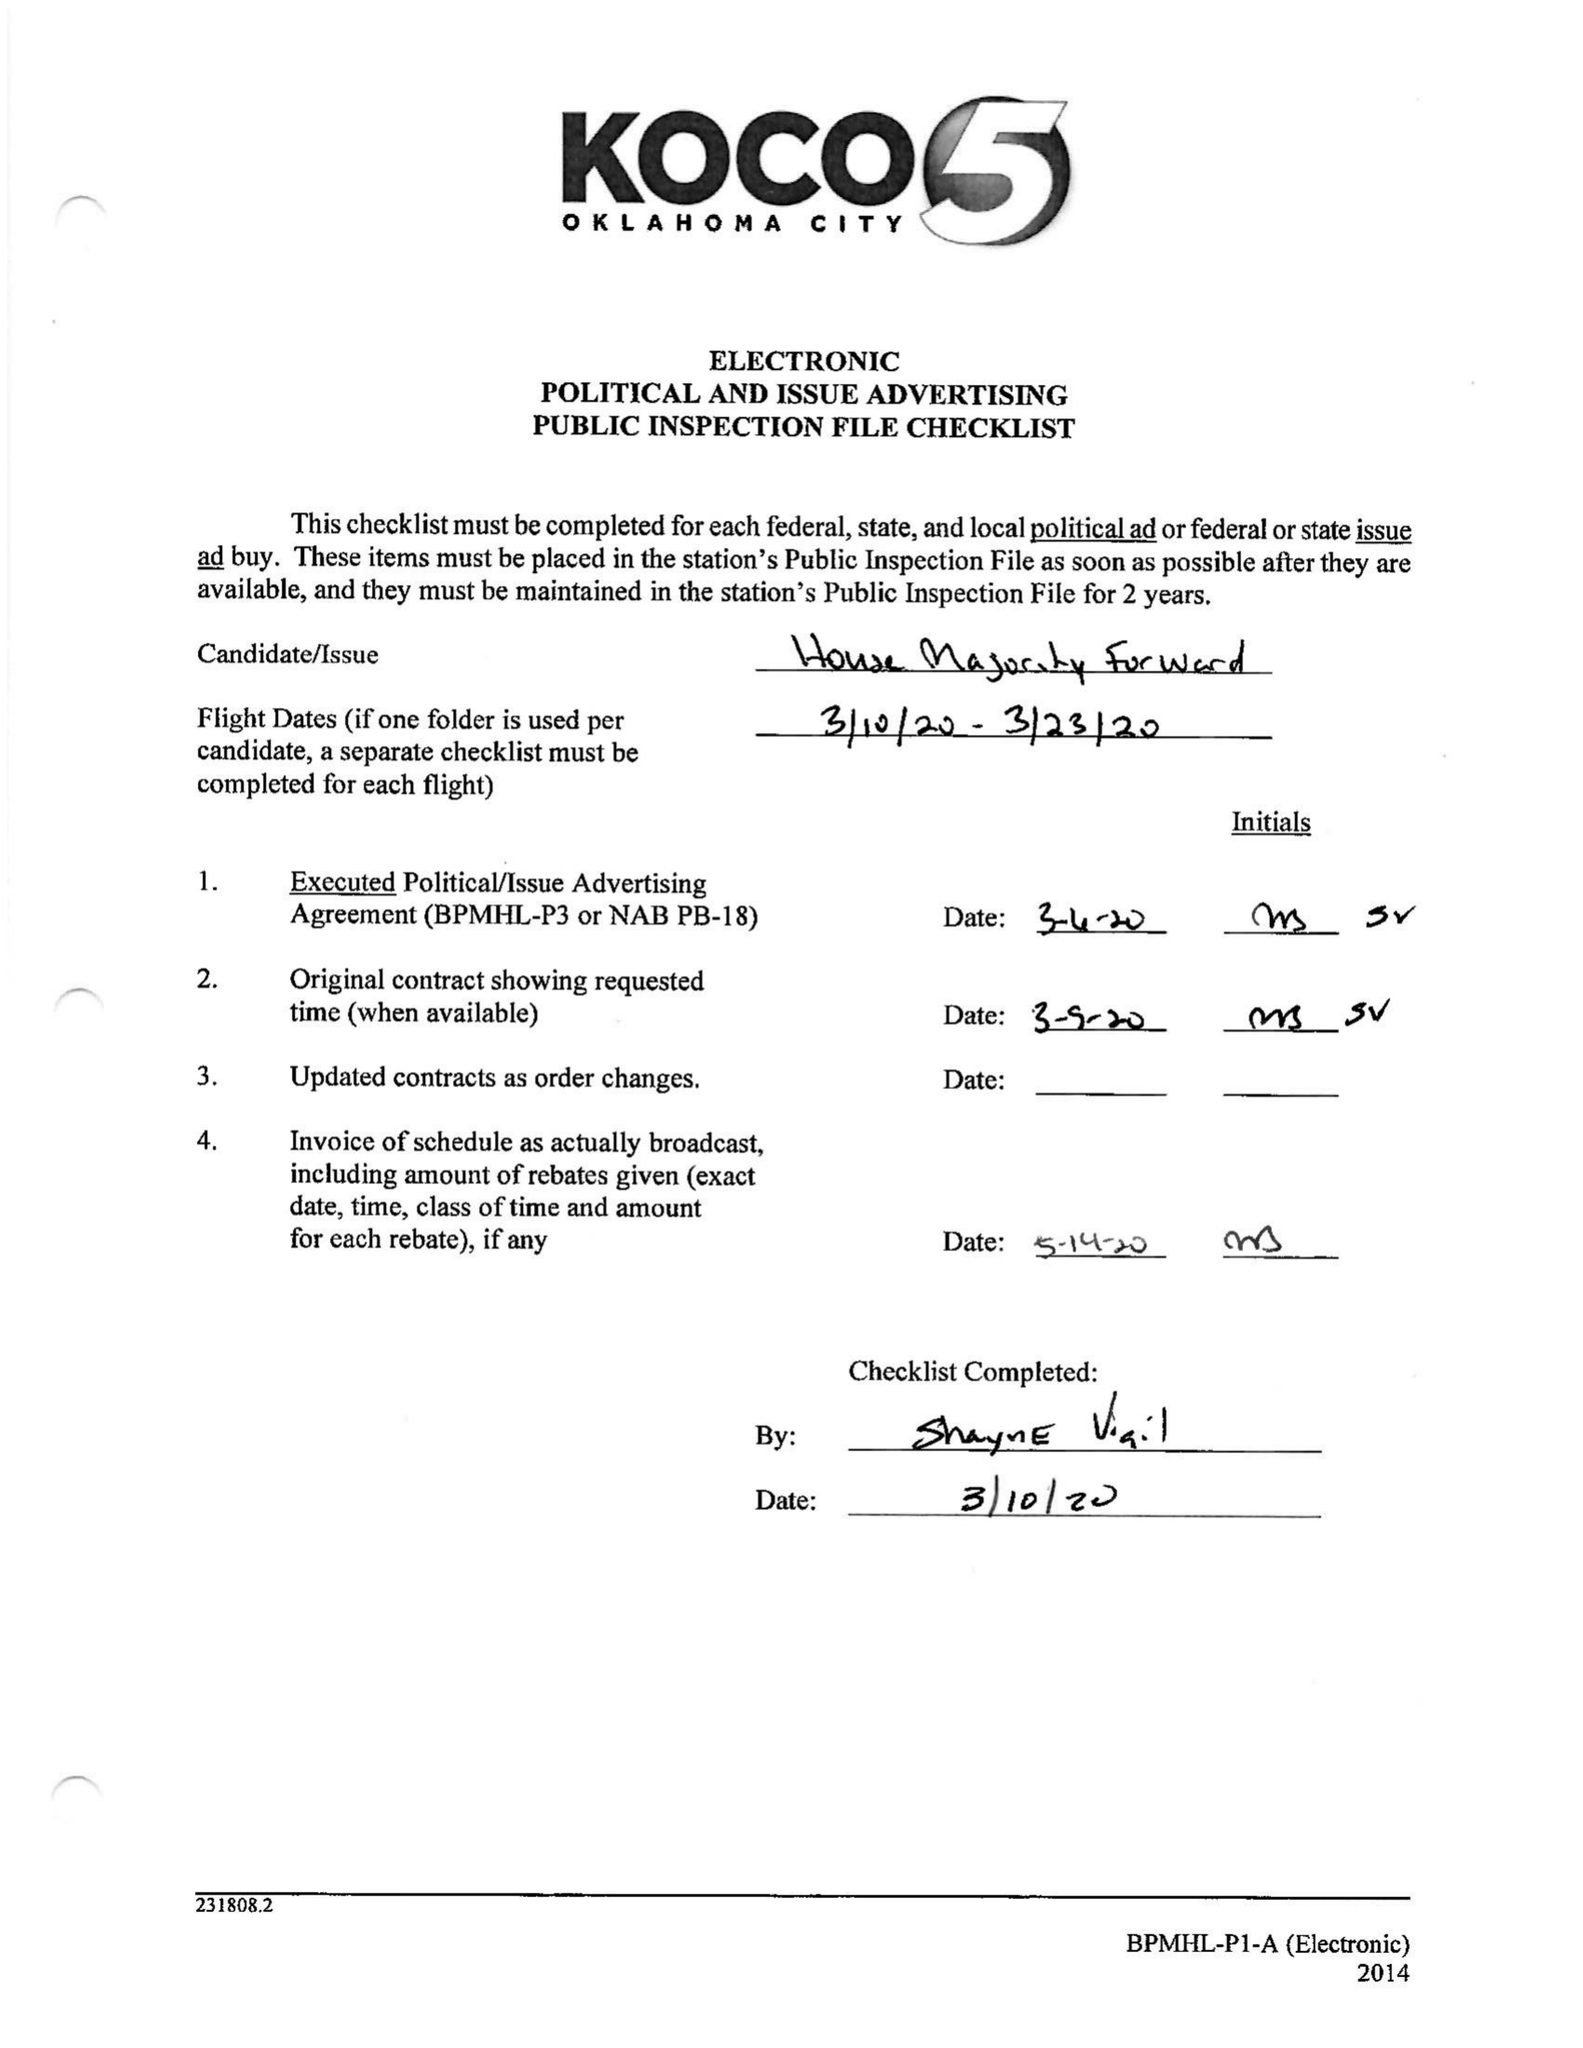What is the value for the contract_num?
Answer the question using a single word or phrase. 1989469 